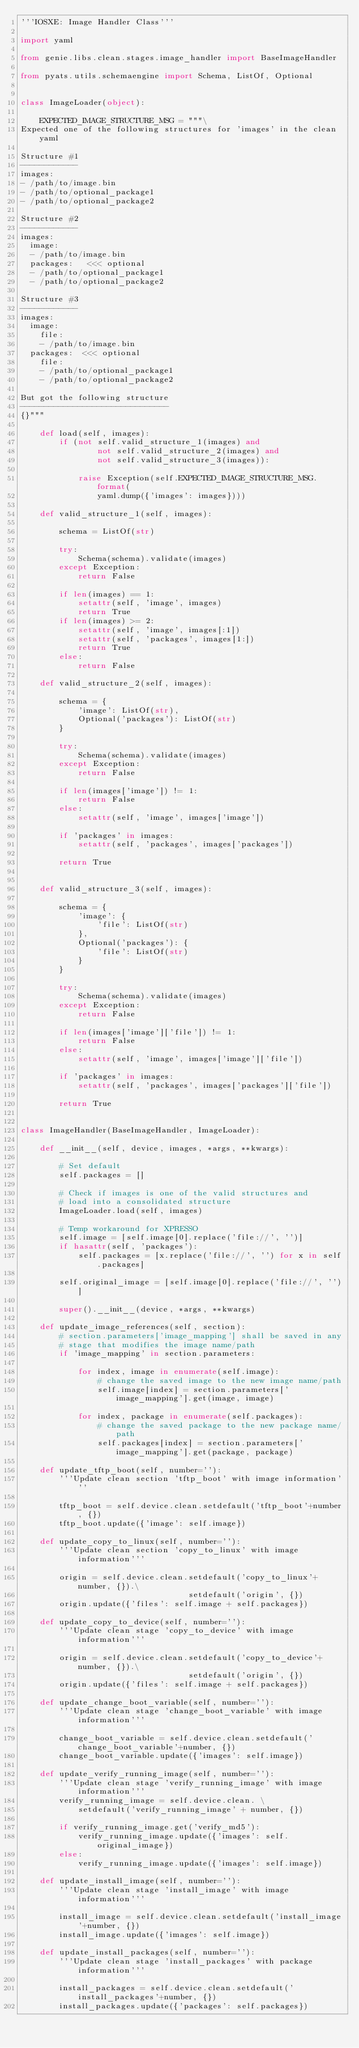<code> <loc_0><loc_0><loc_500><loc_500><_Python_>'''IOSXE: Image Handler Class'''

import yaml

from genie.libs.clean.stages.image_handler import BaseImageHandler

from pyats.utils.schemaengine import Schema, ListOf, Optional


class ImageLoader(object):

    EXPECTED_IMAGE_STRUCTURE_MSG = """\
Expected one of the following structures for 'images' in the clean yaml

Structure #1
------------
images:
- /path/to/image.bin
- /path/to/optional_package1
- /path/to/optional_package2

Structure #2
------------
images:
  image:
  - /path/to/image.bin
  packages:   <<< optional
  - /path/to/optional_package1
  - /path/to/optional_package2

Structure #3
------------
images:
  image:
    file:
    - /path/to/image.bin
  packages:  <<< optional
    file:
    - /path/to/optional_package1
    - /path/to/optional_package2

But got the following structure
-------------------------------
{}"""

    def load(self, images):
        if (not self.valid_structure_1(images) and
                not self.valid_structure_2(images) and
                not self.valid_structure_3(images)):

            raise Exception(self.EXPECTED_IMAGE_STRUCTURE_MSG.format(
                yaml.dump({'images': images})))

    def valid_structure_1(self, images):

        schema = ListOf(str)

        try:
            Schema(schema).validate(images)
        except Exception:
            return False

        if len(images) == 1:
            setattr(self, 'image', images)
            return True
        if len(images) >= 2:
            setattr(self, 'image', images[:1])
            setattr(self, 'packages', images[1:])
            return True
        else:
            return False

    def valid_structure_2(self, images):

        schema = {
            'image': ListOf(str),
            Optional('packages'): ListOf(str)
        }

        try:
            Schema(schema).validate(images)
        except Exception:
            return False

        if len(images['image']) != 1:
            return False
        else:
            setattr(self, 'image', images['image'])

        if 'packages' in images:
            setattr(self, 'packages', images['packages'])

        return True


    def valid_structure_3(self, images):

        schema = {
            'image': {
                'file': ListOf(str)
            },
            Optional('packages'): {
                'file': ListOf(str)
            }
        }

        try:
            Schema(schema).validate(images)
        except Exception:
            return False

        if len(images['image']['file']) != 1:
            return False
        else:
            setattr(self, 'image', images['image']['file'])

        if 'packages' in images:
            setattr(self, 'packages', images['packages']['file'])

        return True


class ImageHandler(BaseImageHandler, ImageLoader):

    def __init__(self, device, images, *args, **kwargs):

        # Set default
        self.packages = []

        # Check if images is one of the valid structures and
        # load into a consolidated structure
        ImageLoader.load(self, images)

        # Temp workaround for XPRESSO
        self.image = [self.image[0].replace('file://', '')]
        if hasattr(self, 'packages'):
            self.packages = [x.replace('file://', '') for x in self.packages]

        self.original_image = [self.image[0].replace('file://', '')]

        super().__init__(device, *args, **kwargs)

    def update_image_references(self, section):
        # section.parameters['image_mapping'] shall be saved in any
        # stage that modifies the image name/path
        if 'image_mapping' in section.parameters:

            for index, image in enumerate(self.image):
                # change the saved image to the new image name/path
                self.image[index] = section.parameters['image_mapping'].get(image, image)

            for index, package in enumerate(self.packages):
                # change the saved package to the new package name/path
                self.packages[index] = section.parameters['image_mapping'].get(package, package)

    def update_tftp_boot(self, number=''):
        '''Update clean section 'tftp_boot' with image information'''

        tftp_boot = self.device.clean.setdefault('tftp_boot'+number, {})
        tftp_boot.update({'image': self.image})

    def update_copy_to_linux(self, number=''):
        '''Update clean section 'copy_to_linux' with image information'''

        origin = self.device.clean.setdefault('copy_to_linux'+number, {}).\
                                   setdefault('origin', {})
        origin.update({'files': self.image + self.packages})

    def update_copy_to_device(self, number=''):
        '''Update clean stage 'copy_to_device' with image information'''

        origin = self.device.clean.setdefault('copy_to_device'+number, {}).\
                                   setdefault('origin', {})
        origin.update({'files': self.image + self.packages})

    def update_change_boot_variable(self, number=''):
        '''Update clean stage 'change_boot_variable' with image information'''

        change_boot_variable = self.device.clean.setdefault('change_boot_variable'+number, {})
        change_boot_variable.update({'images': self.image})

    def update_verify_running_image(self, number=''):
        '''Update clean stage 'verify_running_image' with image information'''
        verify_running_image = self.device.clean. \
            setdefault('verify_running_image' + number, {})

        if verify_running_image.get('verify_md5'):
            verify_running_image.update({'images': self.original_image})
        else:
            verify_running_image.update({'images': self.image})

    def update_install_image(self, number=''):
        '''Update clean stage 'install_image' with image information'''

        install_image = self.device.clean.setdefault('install_image'+number, {})
        install_image.update({'images': self.image})

    def update_install_packages(self, number=''):
        '''Update clean stage 'install_packages' with package information'''

        install_packages = self.device.clean.setdefault('install_packages'+number, {})
        install_packages.update({'packages': self.packages})
</code> 